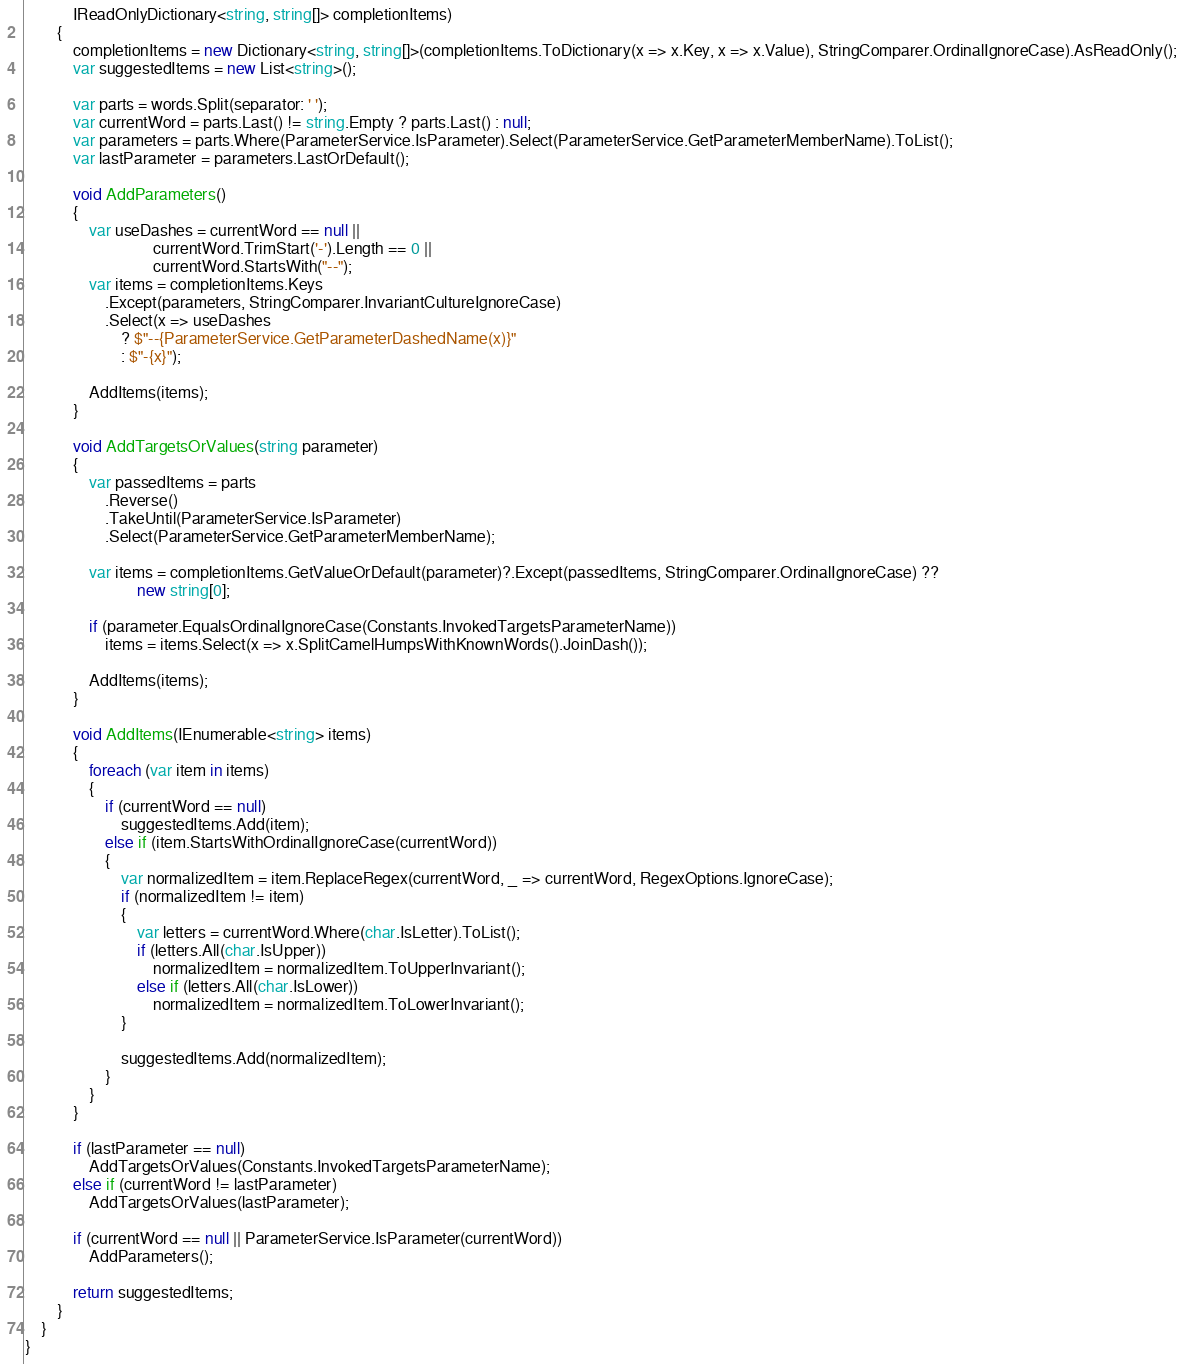<code> <loc_0><loc_0><loc_500><loc_500><_C#_>            IReadOnlyDictionary<string, string[]> completionItems)
        {
            completionItems = new Dictionary<string, string[]>(completionItems.ToDictionary(x => x.Key, x => x.Value), StringComparer.OrdinalIgnoreCase).AsReadOnly();
            var suggestedItems = new List<string>();

            var parts = words.Split(separator: ' ');
            var currentWord = parts.Last() != string.Empty ? parts.Last() : null;
            var parameters = parts.Where(ParameterService.IsParameter).Select(ParameterService.GetParameterMemberName).ToList();
            var lastParameter = parameters.LastOrDefault();

            void AddParameters()
            {
                var useDashes = currentWord == null ||
                                currentWord.TrimStart('-').Length == 0 ||
                                currentWord.StartsWith("--");
                var items = completionItems.Keys
                    .Except(parameters, StringComparer.InvariantCultureIgnoreCase)
                    .Select(x => useDashes
                        ? $"--{ParameterService.GetParameterDashedName(x)}"
                        : $"-{x}");

                AddItems(items);
            }

            void AddTargetsOrValues(string parameter)
            {
                var passedItems = parts
                    .Reverse()
                    .TakeUntil(ParameterService.IsParameter)
                    .Select(ParameterService.GetParameterMemberName);

                var items = completionItems.GetValueOrDefault(parameter)?.Except(passedItems, StringComparer.OrdinalIgnoreCase) ??
                            new string[0];

                if (parameter.EqualsOrdinalIgnoreCase(Constants.InvokedTargetsParameterName))
                    items = items.Select(x => x.SplitCamelHumpsWithKnownWords().JoinDash());

                AddItems(items);
            }

            void AddItems(IEnumerable<string> items)
            {
                foreach (var item in items)
                {
                    if (currentWord == null)
                        suggestedItems.Add(item);
                    else if (item.StartsWithOrdinalIgnoreCase(currentWord))
                    {
                        var normalizedItem = item.ReplaceRegex(currentWord, _ => currentWord, RegexOptions.IgnoreCase);
                        if (normalizedItem != item)
                        {
                            var letters = currentWord.Where(char.IsLetter).ToList();
                            if (letters.All(char.IsUpper))
                                normalizedItem = normalizedItem.ToUpperInvariant();
                            else if (letters.All(char.IsLower))
                                normalizedItem = normalizedItem.ToLowerInvariant();
                        }

                        suggestedItems.Add(normalizedItem);
                    }
                }
            }

            if (lastParameter == null)
                AddTargetsOrValues(Constants.InvokedTargetsParameterName);
            else if (currentWord != lastParameter)
                AddTargetsOrValues(lastParameter);

            if (currentWord == null || ParameterService.IsParameter(currentWord))
                AddParameters();

            return suggestedItems;
        }
    }
}
</code> 